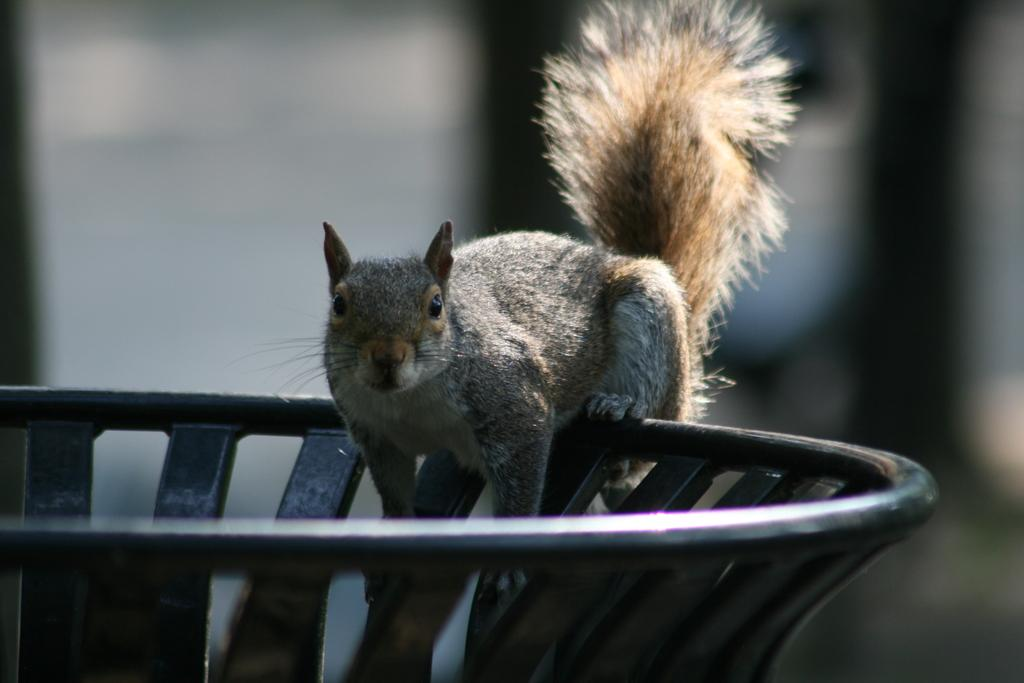What type of animal is in the image? There is a squirrel in the image. What is the squirrel standing on? The squirrel is on an iron object. Can you describe the background of the image? The background of the image is blurred. What type of key is hanging around the squirrel's neck in the image? There is no key present in the image, nor is the squirrel wearing anything around its neck. 